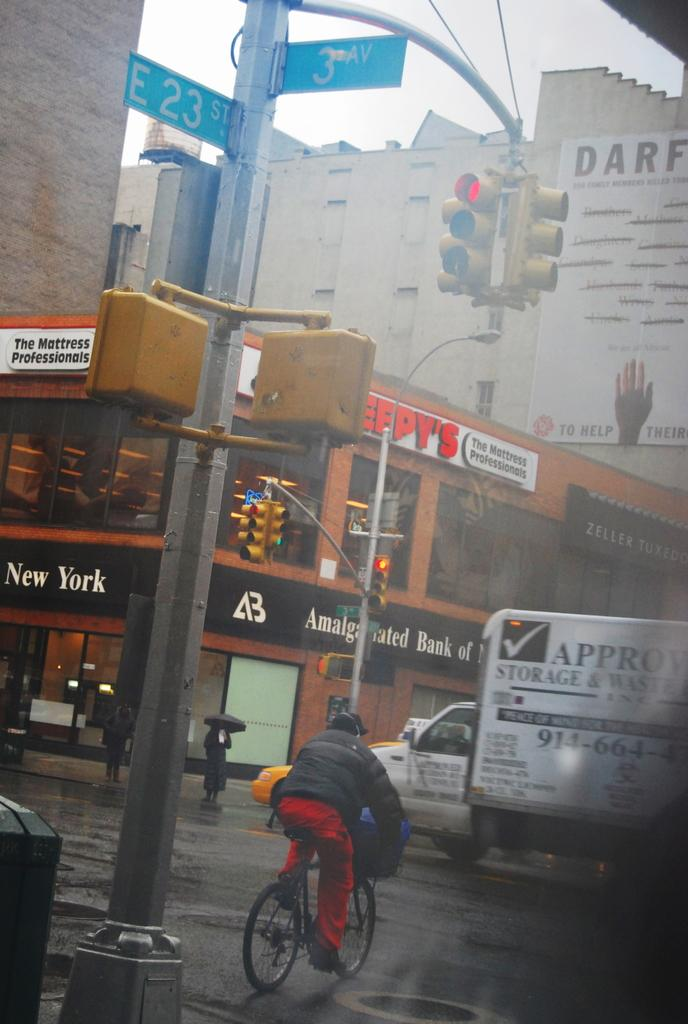What type of pathway is visible in the image? There is a road in the image. What mode of transportation can be seen on the road? There is a vehicle in the image. What other mode of transportation is present in the image? There is a bicycle in the image. What structure is visible near the road? There is a light pole in the image. What type of building is in the background of the image? There is a building in the image. What additional object can be seen in the image? There is a sign in the image. Who is using the bicycle in the image? There is a person riding the bicycle. What is the nature of the image? The image is a poster. Can you tell me how many wires are connected to the light pole in the image? There is no information about the number of wires connected to the light pole in the image. What type of game is being played on the road in the image? There is no game, such as chess, being played on the road in the image. What type of bird is present in the image? There is no bird, such as a turkey, present in the image. 